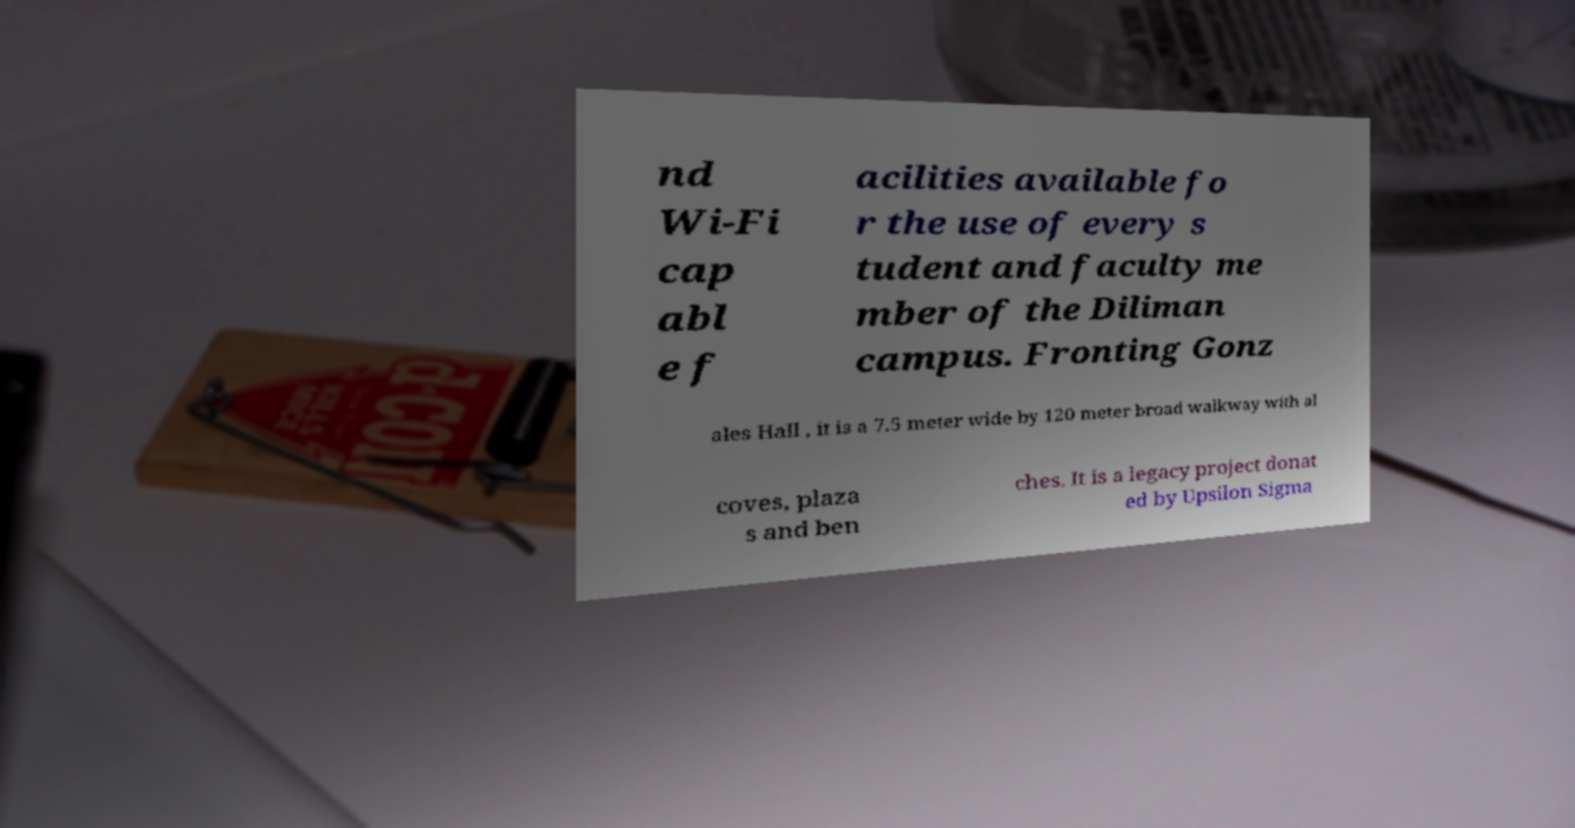Could you extract and type out the text from this image? nd Wi-Fi cap abl e f acilities available fo r the use of every s tudent and faculty me mber of the Diliman campus. Fronting Gonz ales Hall , it is a 7.5 meter wide by 120 meter broad walkway with al coves, plaza s and ben ches. It is a legacy project donat ed by Upsilon Sigma 